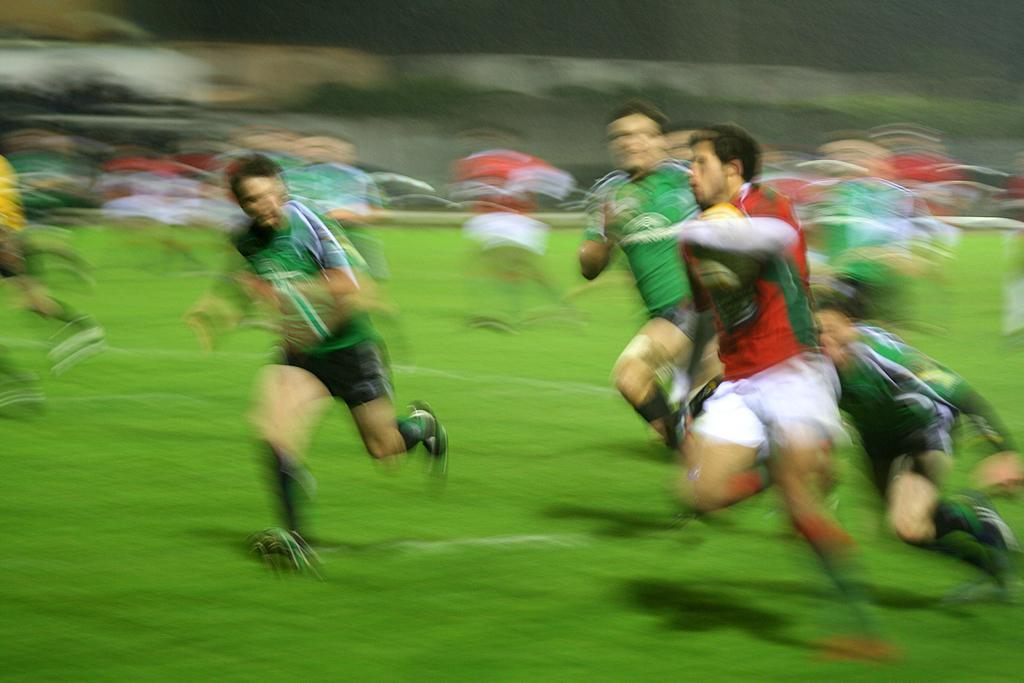What are the people in the image doing? The people in the image are running in the center of the image. What type of surface are the people running on? The people are running on grass, which can be seen at the bottom of the image. What type of flower can be seen growing in the grass in the image? There is no flower visible in the image; it only shows people running on grass. 